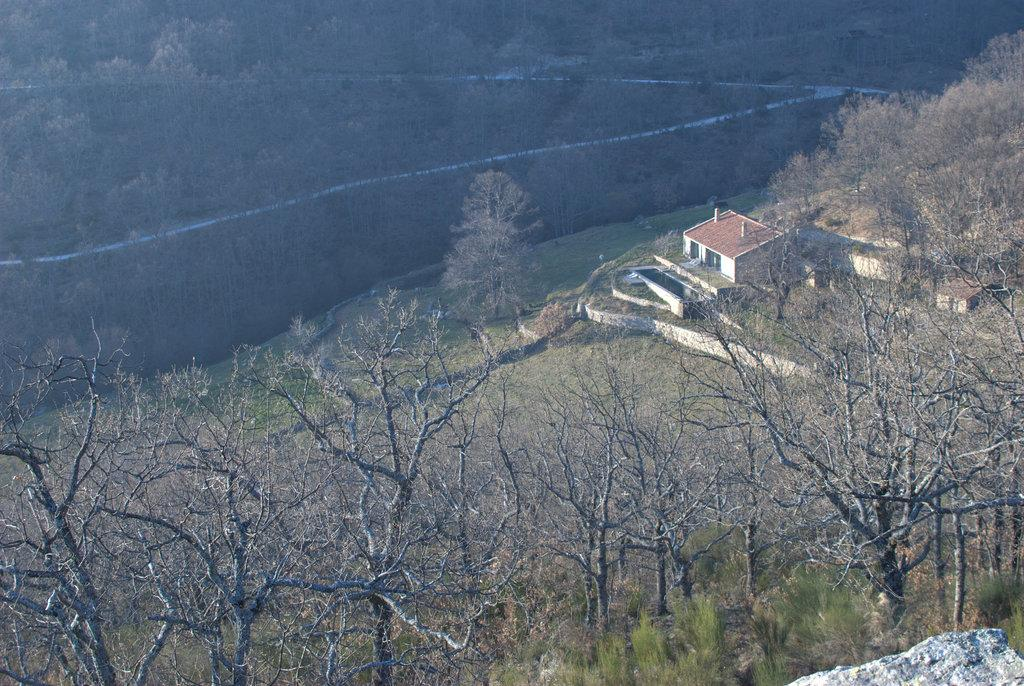What type of vegetation can be seen in the image? There are trees in the image. What type of structure is present in the image? There is a shed in the image. What type of pathway is visible in the image? There is a road in the image. Where is the sink located in the image? There is no sink present in the image. What type of books can be seen on the trees in the image? There are no books present in the image, and trees do not have the ability to hold books. 